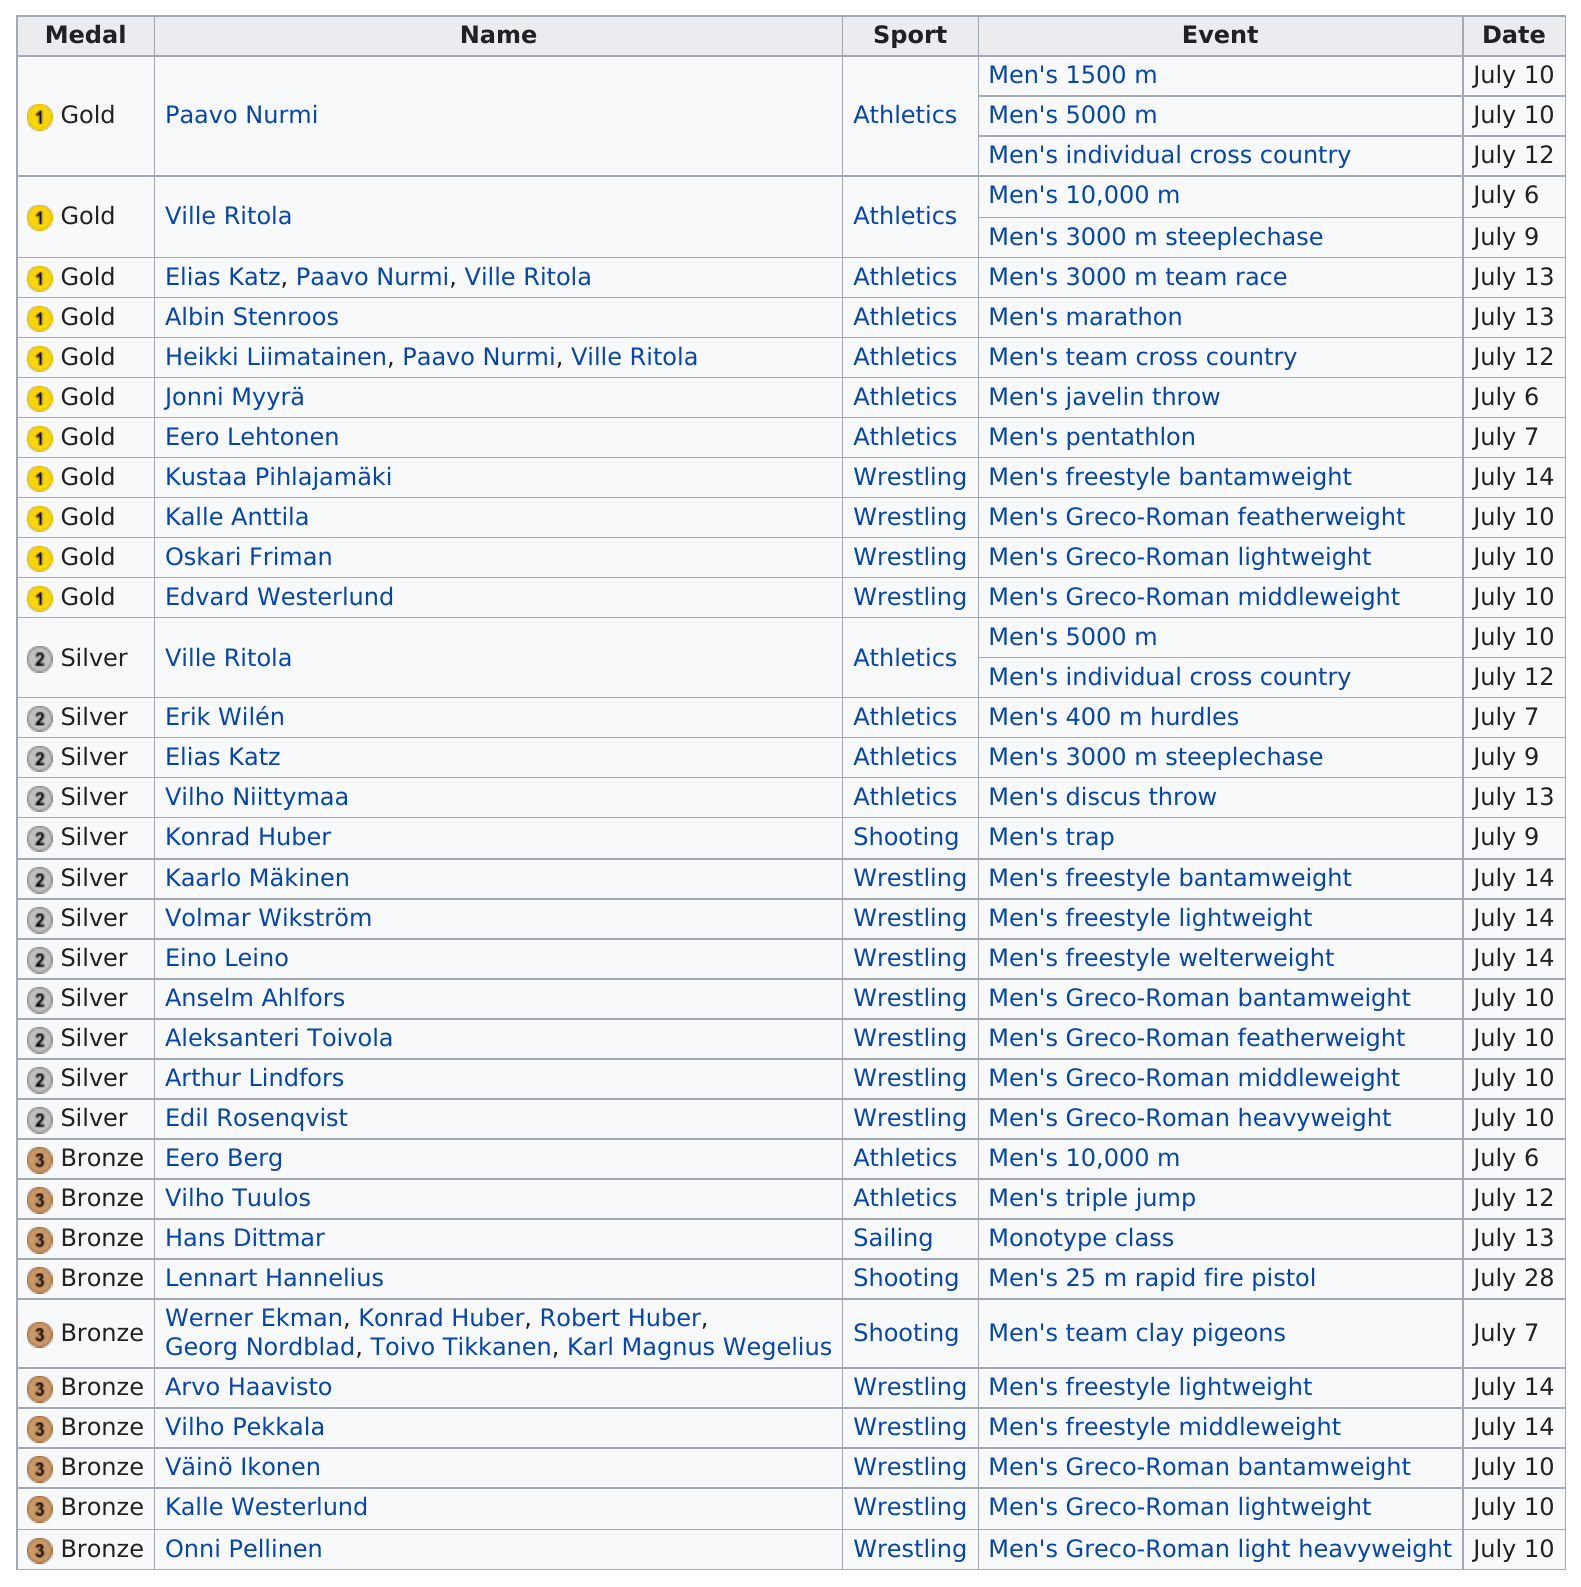Identify some key points in this picture. The athlete from Finland who received a gold medal and a silver medal in the 1924 Summer Olympics was Ville Ritola. Finland won a total of 22 silver and bronze medals at the 1924 Summer Olympics. There are more than two winners in the third-placed medals listed. We awarded 12 silver medals in total. Eero Lehtonen won his gold medal on July 7. 